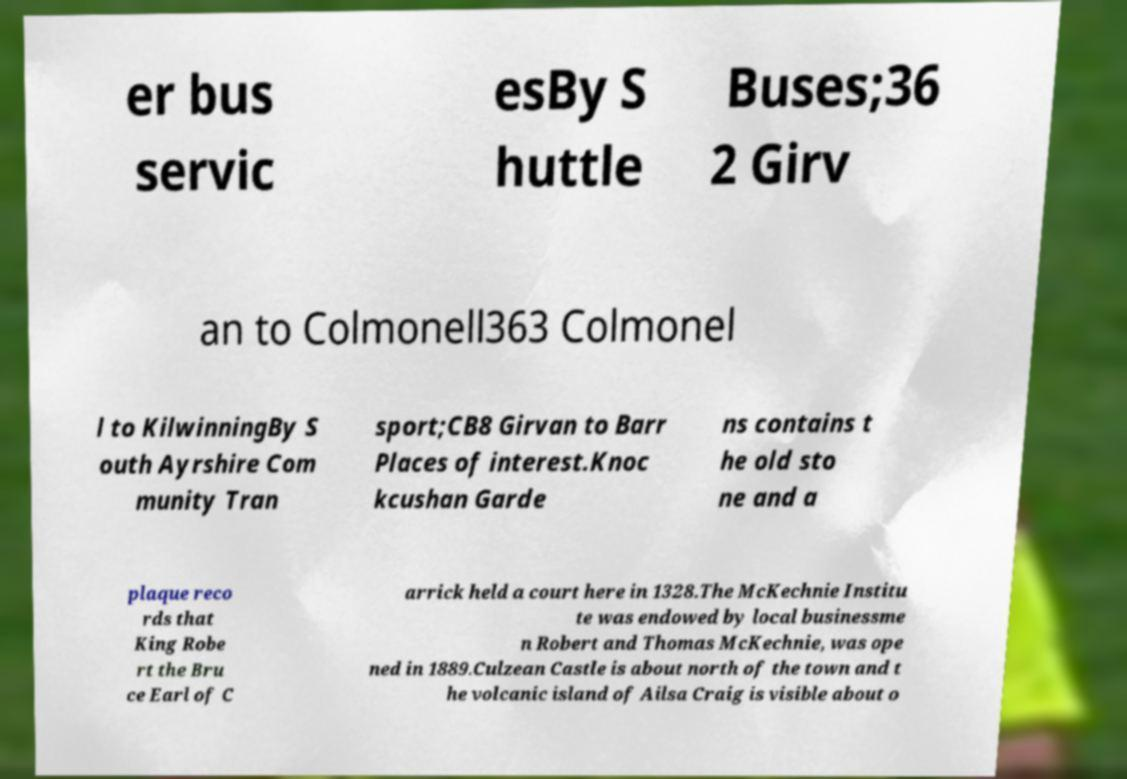Could you assist in decoding the text presented in this image and type it out clearly? er bus servic esBy S huttle Buses;36 2 Girv an to Colmonell363 Colmonel l to KilwinningBy S outh Ayrshire Com munity Tran sport;CB8 Girvan to Barr Places of interest.Knoc kcushan Garde ns contains t he old sto ne and a plaque reco rds that King Robe rt the Bru ce Earl of C arrick held a court here in 1328.The McKechnie Institu te was endowed by local businessme n Robert and Thomas McKechnie, was ope ned in 1889.Culzean Castle is about north of the town and t he volcanic island of Ailsa Craig is visible about o 